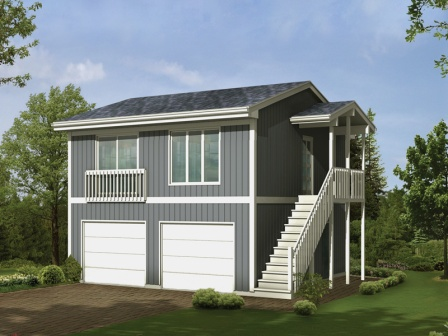If this house were to be a part of a story, what kind of story would it be? In a quaint, picturesque town, this charming gray house belonged to a kind-hearted artist named Elise. Known for her beautiful landscape paintings, Elise hosted weekend art workshops on her second-floor porch, basking in the gentle morning sunlight. The house, a beacon of creativity, often inspired her students, who found solace and inspiration in its serene environs. Little did they know, hidden within its walls was an ancient, mysterious attic that held the key to Elise's untold family history, unlocking secrets and adventures that spanned centuries, just waiting to be discovered. That sounds intriguing! What exactly is hidden in the attic? The attic, a forgotten relic of the house, contains an array of antique items and paintings, each holding a piece of the family's storied past. Among these treasures is a dusty journal from the 1800s, penned by Elise's great-great-grandmother, Eleanor, who was also an artist. The journal recounts Eleanor's travels, her encounters with enigmatic figures, and her secret involvement in a historical event that shaped the nation. Additionally, there is an intricately carved chest containing old maps, letters, and a cryptic key, all hinting at a grand adventure waiting for Elise to embark upon. 